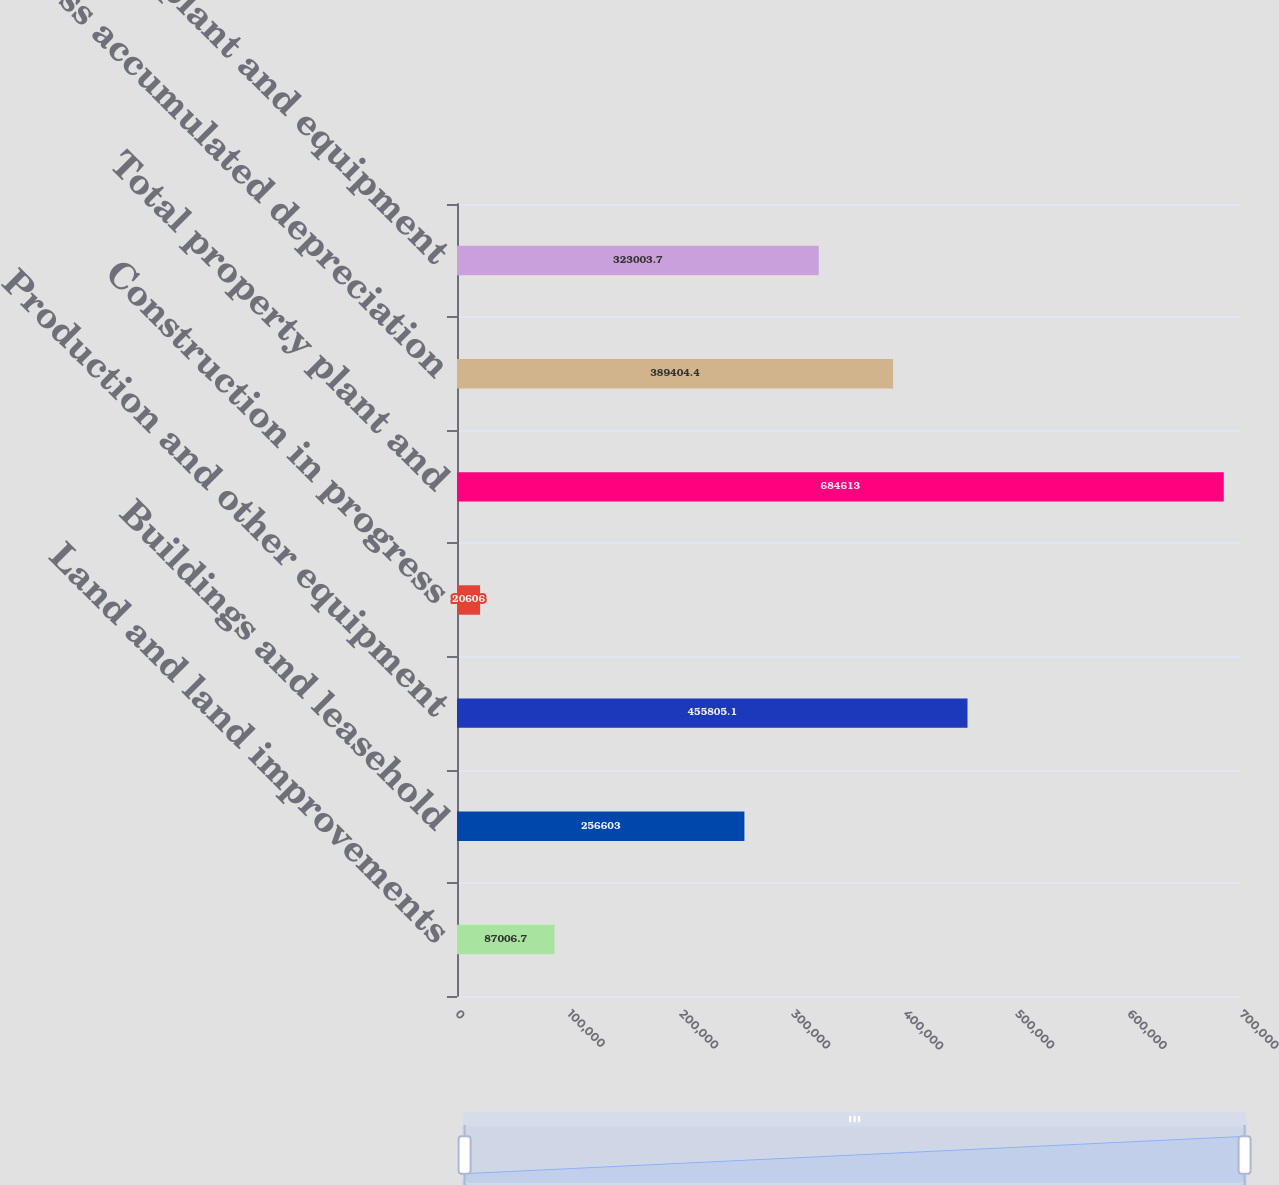Convert chart. <chart><loc_0><loc_0><loc_500><loc_500><bar_chart><fcel>Land and land improvements<fcel>Buildings and leasehold<fcel>Production and other equipment<fcel>Construction in progress<fcel>Total property plant and<fcel>Less accumulated depreciation<fcel>Property plant and equipment<nl><fcel>87006.7<fcel>256603<fcel>455805<fcel>20606<fcel>684613<fcel>389404<fcel>323004<nl></chart> 